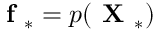Convert formula to latex. <formula><loc_0><loc_0><loc_500><loc_500>f _ { * } = p ( X _ { * } )</formula> 